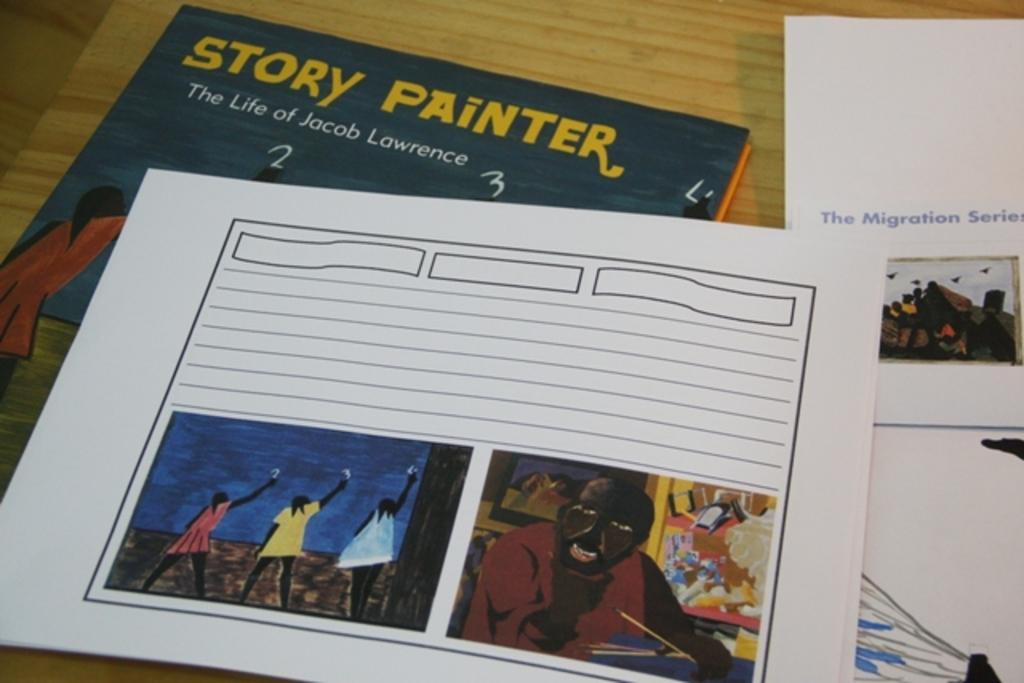<image>
Present a compact description of the photo's key features. A book titled Story Painter is on a table. 